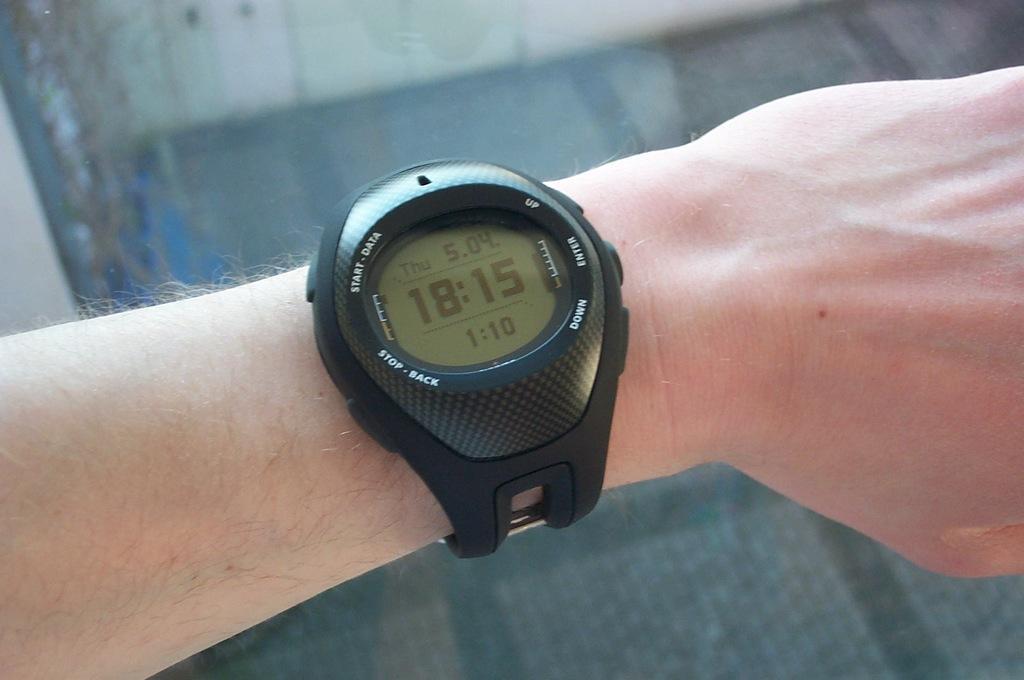What part of a person's body is visible in the image? There is a person's hand in the image. What accessory is visible on the person's hand? The person's hand has a black color watch. What type of cave can be seen in the background of the image? There is no cave present in the image; it only shows a person's hand with a black color watch. 